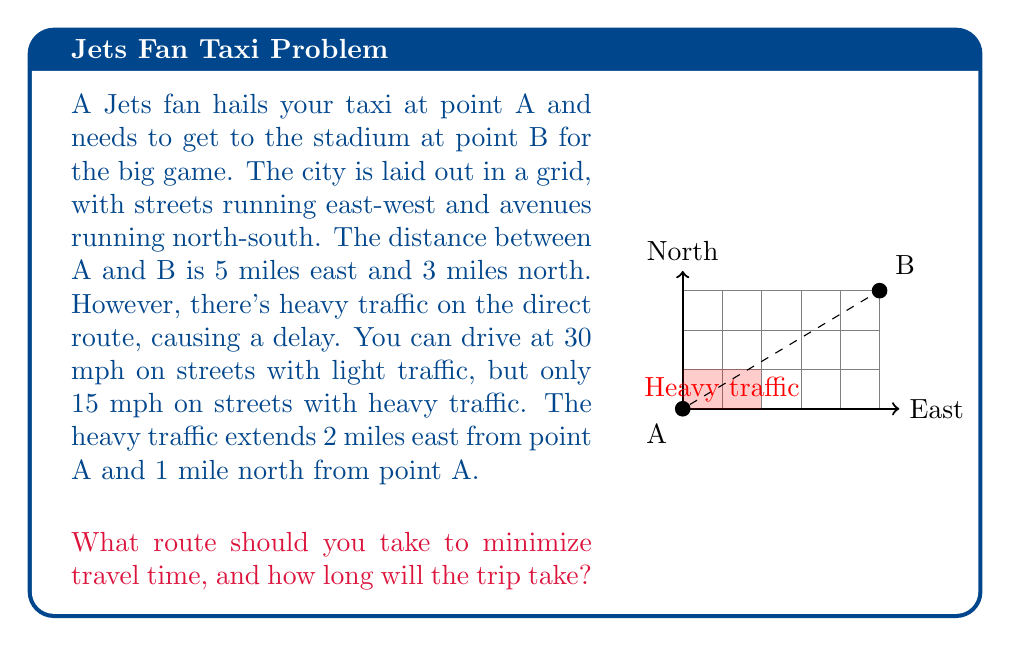Solve this math problem. Let's approach this step-by-step:

1) First, let's consider the total distance:
   East: 5 miles
   North: 3 miles
   Total: 8 miles

2) Now, let's look at the heavy traffic area:
   2 miles east and 1 mile north from A

3) We have two options:
   a) Go through the heavy traffic area
   b) Go around the heavy traffic area

4) Option a (through heavy traffic):
   - 2 miles east + 1 mile north at 15 mph
   - 3 miles east + 2 miles north at 30 mph
   
   Time = $\frac{3}{15} + \frac{5}{30} = 0.2 + 0.1667 = 0.3667$ hours

5) Option b (around heavy traffic):
   - 1 mile north + 2 miles east at 30 mph
   - 3 miles east + 2 miles north at 30 mph
   
   Time = $\frac{3}{30} + \frac{5}{30} = 0.1 + 0.1667 = 0.2667$ hours

6) Clearly, option b is faster.

7) To convert the time to minutes:
   $0.2667 \times 60 = 16$ minutes

Therefore, the optimal route is to go 1 mile north, then 2 miles east to avoid the heavy traffic area, and then continue 3 miles east and 2 miles north to reach the stadium.
Answer: Go 1 mile north, then 2 miles east, then 3 miles east and 2 miles north. Trip time: 16 minutes. 